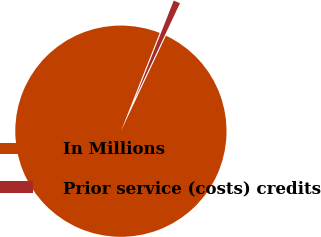Convert chart to OTSL. <chart><loc_0><loc_0><loc_500><loc_500><pie_chart><fcel>In Millions<fcel>Prior service (costs) credits<nl><fcel>98.98%<fcel>1.02%<nl></chart> 